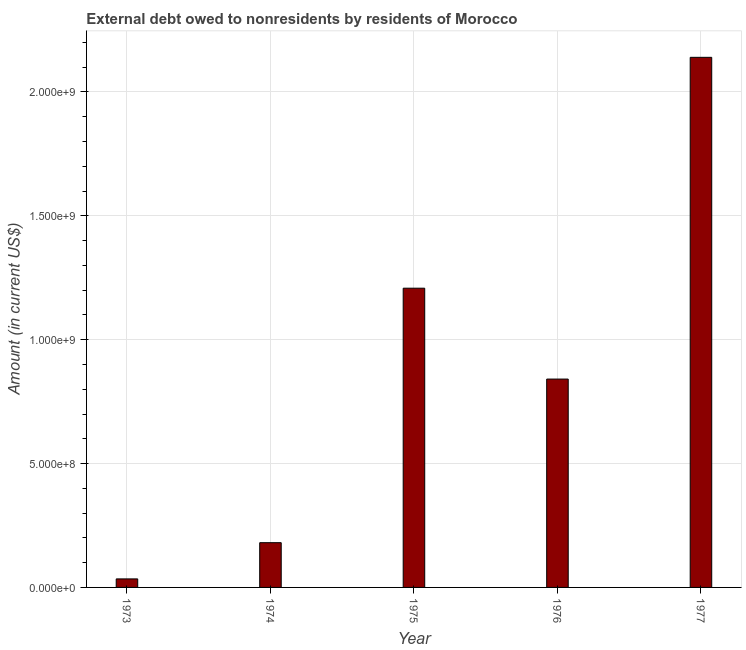Does the graph contain grids?
Your response must be concise. Yes. What is the title of the graph?
Your answer should be very brief. External debt owed to nonresidents by residents of Morocco. What is the label or title of the X-axis?
Your answer should be very brief. Year. What is the label or title of the Y-axis?
Your answer should be very brief. Amount (in current US$). What is the debt in 1976?
Provide a short and direct response. 8.41e+08. Across all years, what is the maximum debt?
Provide a succinct answer. 2.14e+09. Across all years, what is the minimum debt?
Your answer should be compact. 3.44e+07. What is the sum of the debt?
Keep it short and to the point. 4.40e+09. What is the difference between the debt in 1975 and 1976?
Offer a terse response. 3.67e+08. What is the average debt per year?
Your answer should be compact. 8.81e+08. What is the median debt?
Give a very brief answer. 8.41e+08. Do a majority of the years between 1975 and 1974 (inclusive) have debt greater than 400000000 US$?
Provide a succinct answer. No. What is the ratio of the debt in 1973 to that in 1974?
Make the answer very short. 0.19. Is the difference between the debt in 1973 and 1976 greater than the difference between any two years?
Provide a succinct answer. No. What is the difference between the highest and the second highest debt?
Provide a succinct answer. 9.32e+08. What is the difference between the highest and the lowest debt?
Your answer should be very brief. 2.11e+09. How many bars are there?
Provide a succinct answer. 5. How many years are there in the graph?
Provide a short and direct response. 5. Are the values on the major ticks of Y-axis written in scientific E-notation?
Your response must be concise. Yes. What is the Amount (in current US$) in 1973?
Give a very brief answer. 3.44e+07. What is the Amount (in current US$) in 1974?
Offer a terse response. 1.81e+08. What is the Amount (in current US$) in 1975?
Give a very brief answer. 1.21e+09. What is the Amount (in current US$) in 1976?
Make the answer very short. 8.41e+08. What is the Amount (in current US$) in 1977?
Your response must be concise. 2.14e+09. What is the difference between the Amount (in current US$) in 1973 and 1974?
Your answer should be very brief. -1.46e+08. What is the difference between the Amount (in current US$) in 1973 and 1975?
Ensure brevity in your answer.  -1.17e+09. What is the difference between the Amount (in current US$) in 1973 and 1976?
Your response must be concise. -8.07e+08. What is the difference between the Amount (in current US$) in 1973 and 1977?
Ensure brevity in your answer.  -2.11e+09. What is the difference between the Amount (in current US$) in 1974 and 1975?
Offer a very short reply. -1.03e+09. What is the difference between the Amount (in current US$) in 1974 and 1976?
Offer a terse response. -6.60e+08. What is the difference between the Amount (in current US$) in 1974 and 1977?
Give a very brief answer. -1.96e+09. What is the difference between the Amount (in current US$) in 1975 and 1976?
Give a very brief answer. 3.67e+08. What is the difference between the Amount (in current US$) in 1975 and 1977?
Provide a succinct answer. -9.32e+08. What is the difference between the Amount (in current US$) in 1976 and 1977?
Your response must be concise. -1.30e+09. What is the ratio of the Amount (in current US$) in 1973 to that in 1974?
Provide a succinct answer. 0.19. What is the ratio of the Amount (in current US$) in 1973 to that in 1975?
Your answer should be very brief. 0.03. What is the ratio of the Amount (in current US$) in 1973 to that in 1976?
Give a very brief answer. 0.04. What is the ratio of the Amount (in current US$) in 1973 to that in 1977?
Provide a short and direct response. 0.02. What is the ratio of the Amount (in current US$) in 1974 to that in 1975?
Give a very brief answer. 0.15. What is the ratio of the Amount (in current US$) in 1974 to that in 1976?
Give a very brief answer. 0.21. What is the ratio of the Amount (in current US$) in 1974 to that in 1977?
Your response must be concise. 0.08. What is the ratio of the Amount (in current US$) in 1975 to that in 1976?
Make the answer very short. 1.44. What is the ratio of the Amount (in current US$) in 1975 to that in 1977?
Provide a succinct answer. 0.56. What is the ratio of the Amount (in current US$) in 1976 to that in 1977?
Your answer should be very brief. 0.39. 